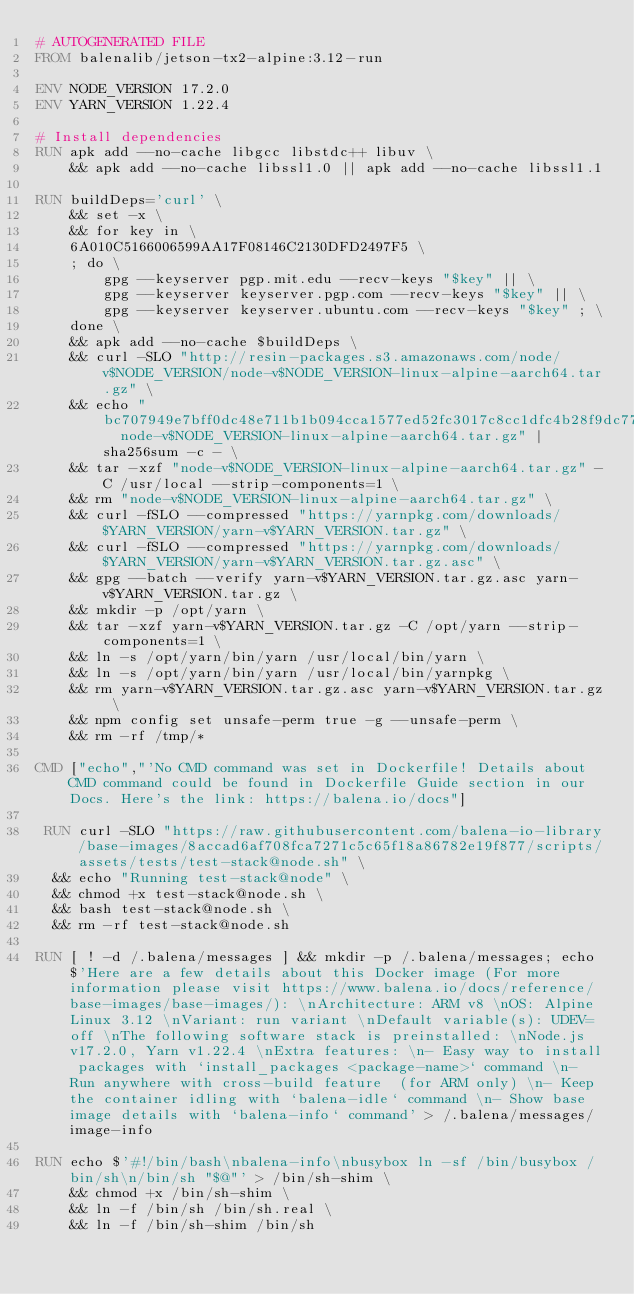Convert code to text. <code><loc_0><loc_0><loc_500><loc_500><_Dockerfile_># AUTOGENERATED FILE
FROM balenalib/jetson-tx2-alpine:3.12-run

ENV NODE_VERSION 17.2.0
ENV YARN_VERSION 1.22.4

# Install dependencies
RUN apk add --no-cache libgcc libstdc++ libuv \
	&& apk add --no-cache libssl1.0 || apk add --no-cache libssl1.1

RUN buildDeps='curl' \
	&& set -x \
	&& for key in \
	6A010C5166006599AA17F08146C2130DFD2497F5 \
	; do \
		gpg --keyserver pgp.mit.edu --recv-keys "$key" || \
		gpg --keyserver keyserver.pgp.com --recv-keys "$key" || \
		gpg --keyserver keyserver.ubuntu.com --recv-keys "$key" ; \
	done \
	&& apk add --no-cache $buildDeps \
	&& curl -SLO "http://resin-packages.s3.amazonaws.com/node/v$NODE_VERSION/node-v$NODE_VERSION-linux-alpine-aarch64.tar.gz" \
	&& echo "bc707949e7bff0dc48e711b1b094cca1577ed52fc3017c8cc1dfc4b28f9dc77f  node-v$NODE_VERSION-linux-alpine-aarch64.tar.gz" | sha256sum -c - \
	&& tar -xzf "node-v$NODE_VERSION-linux-alpine-aarch64.tar.gz" -C /usr/local --strip-components=1 \
	&& rm "node-v$NODE_VERSION-linux-alpine-aarch64.tar.gz" \
	&& curl -fSLO --compressed "https://yarnpkg.com/downloads/$YARN_VERSION/yarn-v$YARN_VERSION.tar.gz" \
	&& curl -fSLO --compressed "https://yarnpkg.com/downloads/$YARN_VERSION/yarn-v$YARN_VERSION.tar.gz.asc" \
	&& gpg --batch --verify yarn-v$YARN_VERSION.tar.gz.asc yarn-v$YARN_VERSION.tar.gz \
	&& mkdir -p /opt/yarn \
	&& tar -xzf yarn-v$YARN_VERSION.tar.gz -C /opt/yarn --strip-components=1 \
	&& ln -s /opt/yarn/bin/yarn /usr/local/bin/yarn \
	&& ln -s /opt/yarn/bin/yarn /usr/local/bin/yarnpkg \
	&& rm yarn-v$YARN_VERSION.tar.gz.asc yarn-v$YARN_VERSION.tar.gz \
	&& npm config set unsafe-perm true -g --unsafe-perm \
	&& rm -rf /tmp/*

CMD ["echo","'No CMD command was set in Dockerfile! Details about CMD command could be found in Dockerfile Guide section in our Docs. Here's the link: https://balena.io/docs"]

 RUN curl -SLO "https://raw.githubusercontent.com/balena-io-library/base-images/8accad6af708fca7271c5c65f18a86782e19f877/scripts/assets/tests/test-stack@node.sh" \
  && echo "Running test-stack@node" \
  && chmod +x test-stack@node.sh \
  && bash test-stack@node.sh \
  && rm -rf test-stack@node.sh 

RUN [ ! -d /.balena/messages ] && mkdir -p /.balena/messages; echo $'Here are a few details about this Docker image (For more information please visit https://www.balena.io/docs/reference/base-images/base-images/): \nArchitecture: ARM v8 \nOS: Alpine Linux 3.12 \nVariant: run variant \nDefault variable(s): UDEV=off \nThe following software stack is preinstalled: \nNode.js v17.2.0, Yarn v1.22.4 \nExtra features: \n- Easy way to install packages with `install_packages <package-name>` command \n- Run anywhere with cross-build feature  (for ARM only) \n- Keep the container idling with `balena-idle` command \n- Show base image details with `balena-info` command' > /.balena/messages/image-info

RUN echo $'#!/bin/bash\nbalena-info\nbusybox ln -sf /bin/busybox /bin/sh\n/bin/sh "$@"' > /bin/sh-shim \
	&& chmod +x /bin/sh-shim \
	&& ln -f /bin/sh /bin/sh.real \
	&& ln -f /bin/sh-shim /bin/sh</code> 